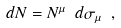Convert formula to latex. <formula><loc_0><loc_0><loc_500><loc_500>d N = N ^ { \mu } \ d \sigma _ { \mu } \ ,</formula> 